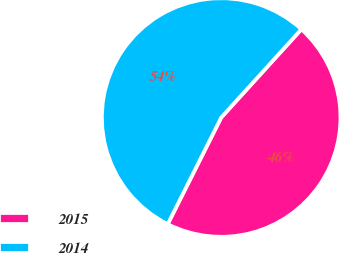Convert chart. <chart><loc_0><loc_0><loc_500><loc_500><pie_chart><fcel>2015<fcel>2014<nl><fcel>45.66%<fcel>54.34%<nl></chart> 